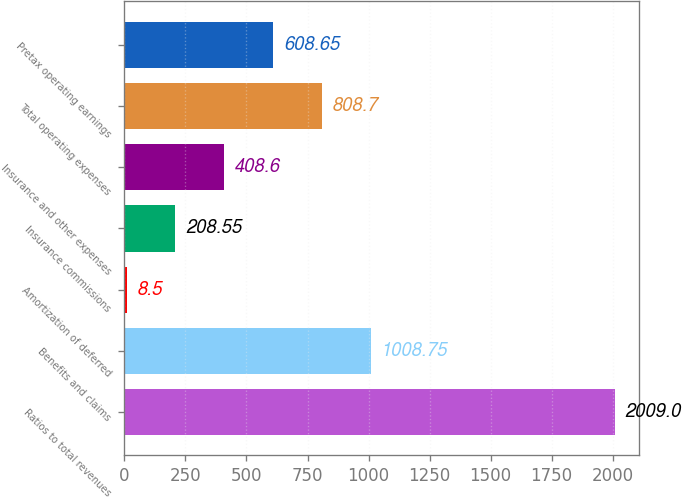Convert chart to OTSL. <chart><loc_0><loc_0><loc_500><loc_500><bar_chart><fcel>Ratios to total revenues<fcel>Benefits and claims<fcel>Amortization of deferred<fcel>Insurance commissions<fcel>Insurance and other expenses<fcel>Total operating expenses<fcel>Pretax operating earnings<nl><fcel>2009<fcel>1008.75<fcel>8.5<fcel>208.55<fcel>408.6<fcel>808.7<fcel>608.65<nl></chart> 